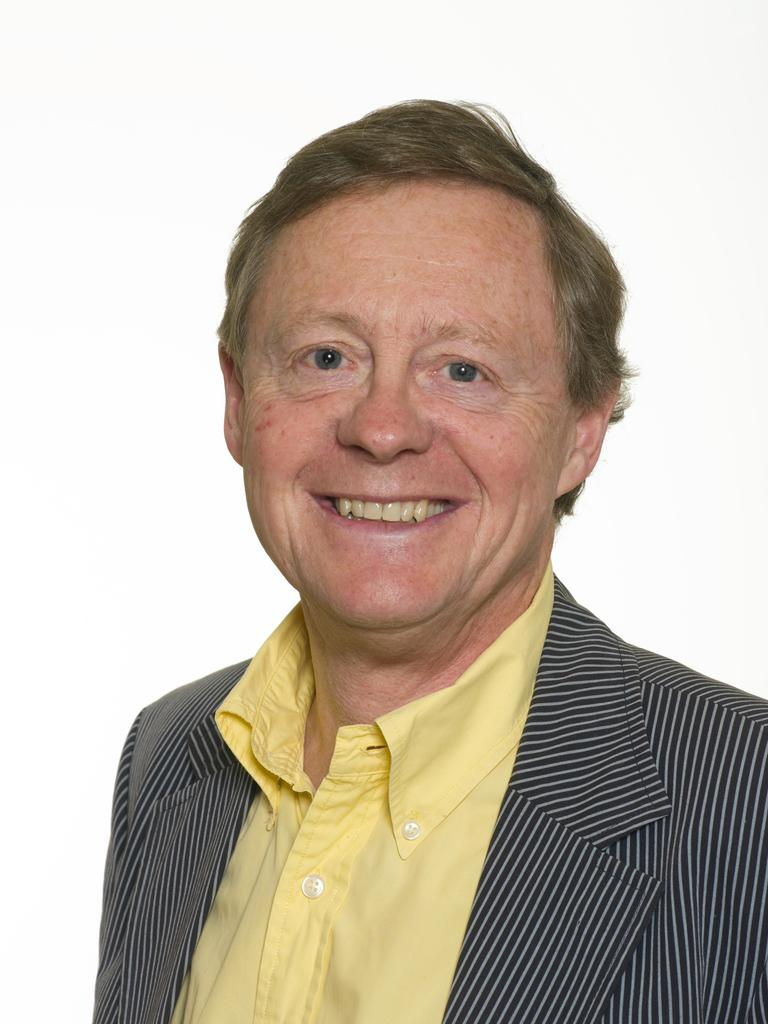Who is present in the image? There is a man in the image. What is the man wearing on his upper body? The man is wearing a blazer and a shirt. What is the man's facial expression in the image? The man is smiling. What color is the background of the image? The background of the image is white. What type of square object is the man holding in the image? There is no square object present in the image. What type of legal advice is the man providing in the image? The image does not depict the man providing legal advice or any other professional service. 